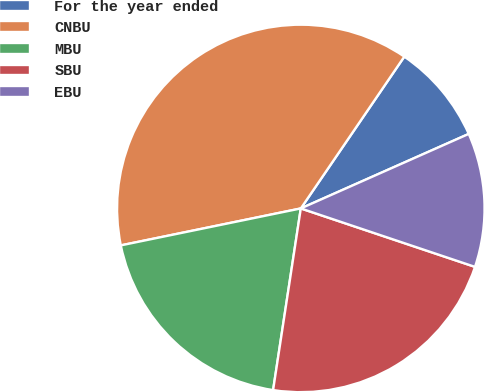Convert chart to OTSL. <chart><loc_0><loc_0><loc_500><loc_500><pie_chart><fcel>For the year ended<fcel>CNBU<fcel>MBU<fcel>SBU<fcel>EBU<nl><fcel>8.83%<fcel>37.75%<fcel>19.37%<fcel>22.26%<fcel>11.8%<nl></chart> 